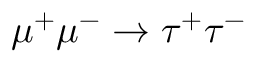<formula> <loc_0><loc_0><loc_500><loc_500>\mu ^ { + } \mu ^ { - } \to \tau ^ { + } \tau ^ { - }</formula> 